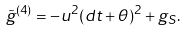Convert formula to latex. <formula><loc_0><loc_0><loc_500><loc_500>\tilde { g } ^ { ( 4 ) } = - u ^ { 2 } ( d t + \theta ) ^ { 2 } + g _ { S } .</formula> 